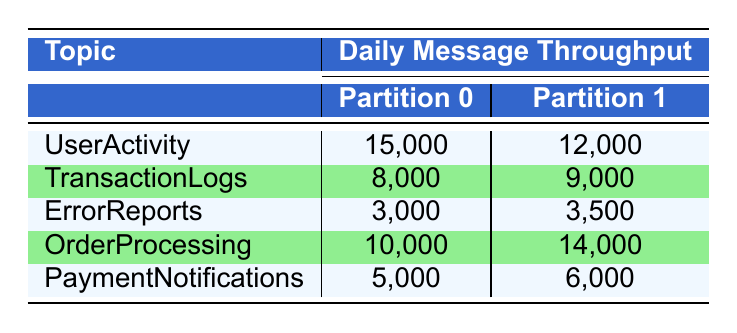What is the daily message throughput for the UserActivity topic at Partition 0? The table shows that for the UserActivity topic, Partition 0 has a throughput of 15,000 messages.
Answer: 15,000 Which topic has the highest throughput in Partition 1? By examining the values in Partition 1, the highest throughput is for the OrderProcessing topic, which is 14,000 messages.
Answer: OrderProcessing What is the total daily message throughput for the TransactionLogs topic? The throughput for TransactionLogs in Partition 0 is 8,000 and in Partition 1 is 9,000. The total is 8,000 + 9,000 = 17,000 messages.
Answer: 17,000 Is the daily message throughput for ErrorReports greater than 6,000? The throughput for ErrorReports in both partitions is 3,000 and 3,500 respectively, which is less than 6,000. Therefore, it is not greater.
Answer: No What is the average daily message throughput for all topics in Partition 0? The throughput for Partition 0 across all topics is 15,000 (UserActivity) + 8,000 (TransactionLogs) + 3,000 (ErrorReports) + 10,000 (OrderProcessing) + 5,000 (PaymentNotifications) = 41,000. The average is 41,000 / 5 = 8,200.
Answer: 8,200 Which topic has the lowest total throughput across both partitions? Calculating the total throughput for each topic: UserActivity is 27,000 (15,000 + 12,000), TransactionLogs is 17,000 (8,000 + 9,000), ErrorReports is 6,500 (3,000 + 3,500), OrderProcessing is 24,000 (10,000 + 14,000), and PaymentNotifications is 11,000 (5,000 + 6,000). The lowest total throughput is for ErrorReports with 6,500.
Answer: ErrorReports How many messages does the PaymentNotifications topic transmit in Partition 1? According to the table, Partition 1 of the PaymentNotifications topic transmits 6,000 messages.
Answer: 6,000 Is the throughput for Partition 0 in OrderProcessing less than that of PaymentNotifications? Partition 0 for OrderProcessing has a throughput of 10,000 messages, and for PaymentNotifications, it is 5,000 messages. Since 10,000 is greater than 5,000, the statement is false.
Answer: No 